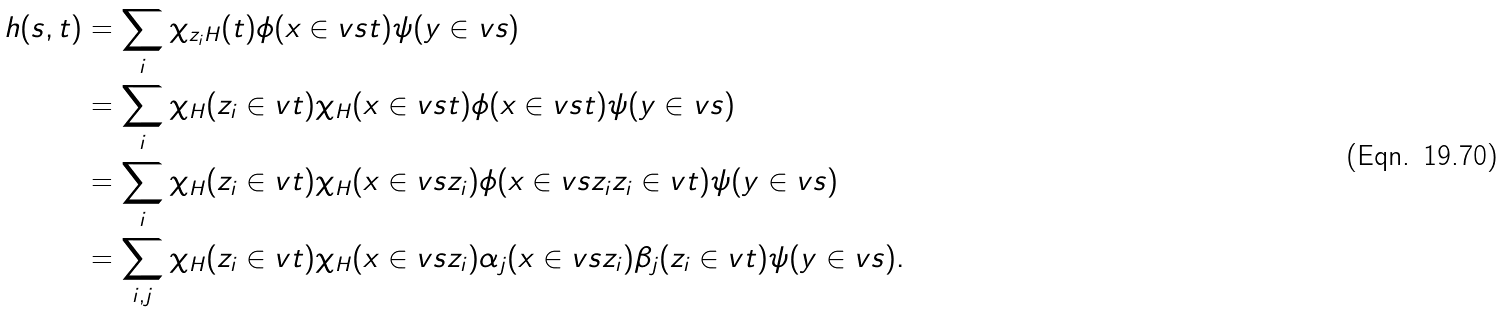Convert formula to latex. <formula><loc_0><loc_0><loc_500><loc_500>h ( s , t ) & = \sum _ { i } \chi _ { z _ { i } H } ( t ) \phi ( x \in v s t ) \psi ( y \in v s ) \\ & = \sum _ { i } \chi _ { H } ( z _ { i } \in v t ) \chi _ { H } ( x \in v s t ) \phi ( x \in v s t ) \psi ( y \in v s ) \\ & = \sum _ { i } \chi _ { H } ( z _ { i } \in v t ) \chi _ { H } ( x \in v s z _ { i } ) \phi ( x \in v s z _ { i } z _ { i } \in v t ) \psi ( y \in v s ) \\ & = \sum _ { i , j } \chi _ { H } ( z _ { i } \in v t ) \chi _ { H } ( x \in v s z _ { i } ) \alpha _ { j } ( x \in v s z _ { i } ) \beta _ { j } ( z _ { i } \in v t ) \psi ( y \in v s ) .</formula> 